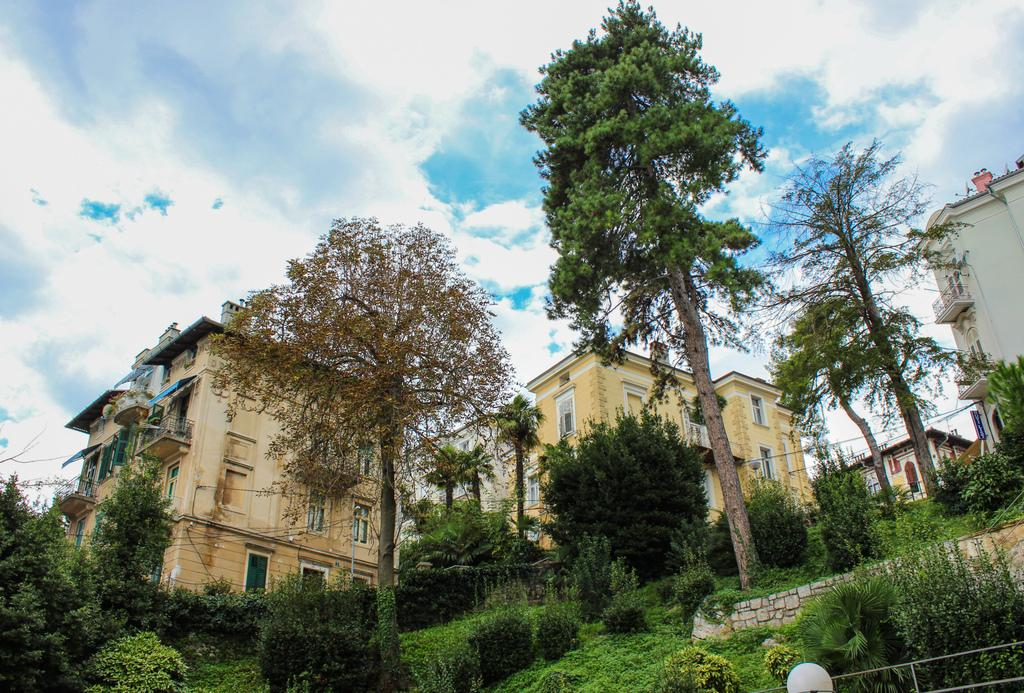What type of natural elements can be seen in the image? There are plants and trees in the image. What type of man-made structures can be seen in the image? There are buildings in the image. What is visible in the background of the image? The sky is visible in the background of the image. What can be observed in the sky in the image? Clouds are present in the sky. Who is the owner of the line visible in the image? There is no line present in the image, so it is not possible to determine an owner. 